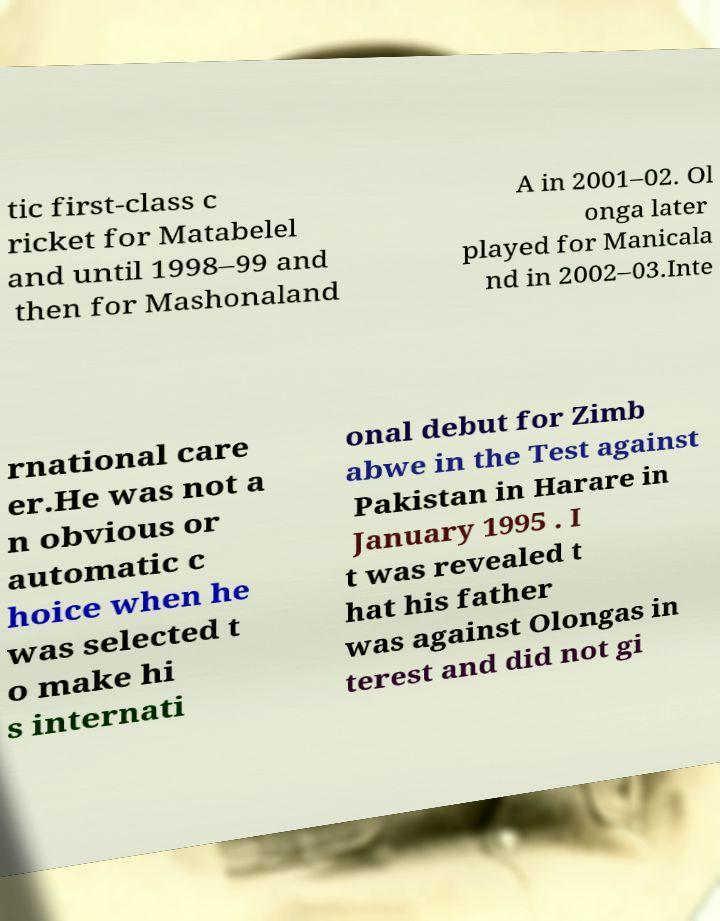Could you assist in decoding the text presented in this image and type it out clearly? tic first-class c ricket for Matabelel and until 1998–99 and then for Mashonaland A in 2001–02. Ol onga later played for Manicala nd in 2002–03.Inte rnational care er.He was not a n obvious or automatic c hoice when he was selected t o make hi s internati onal debut for Zimb abwe in the Test against Pakistan in Harare in January 1995 . I t was revealed t hat his father was against Olongas in terest and did not gi 